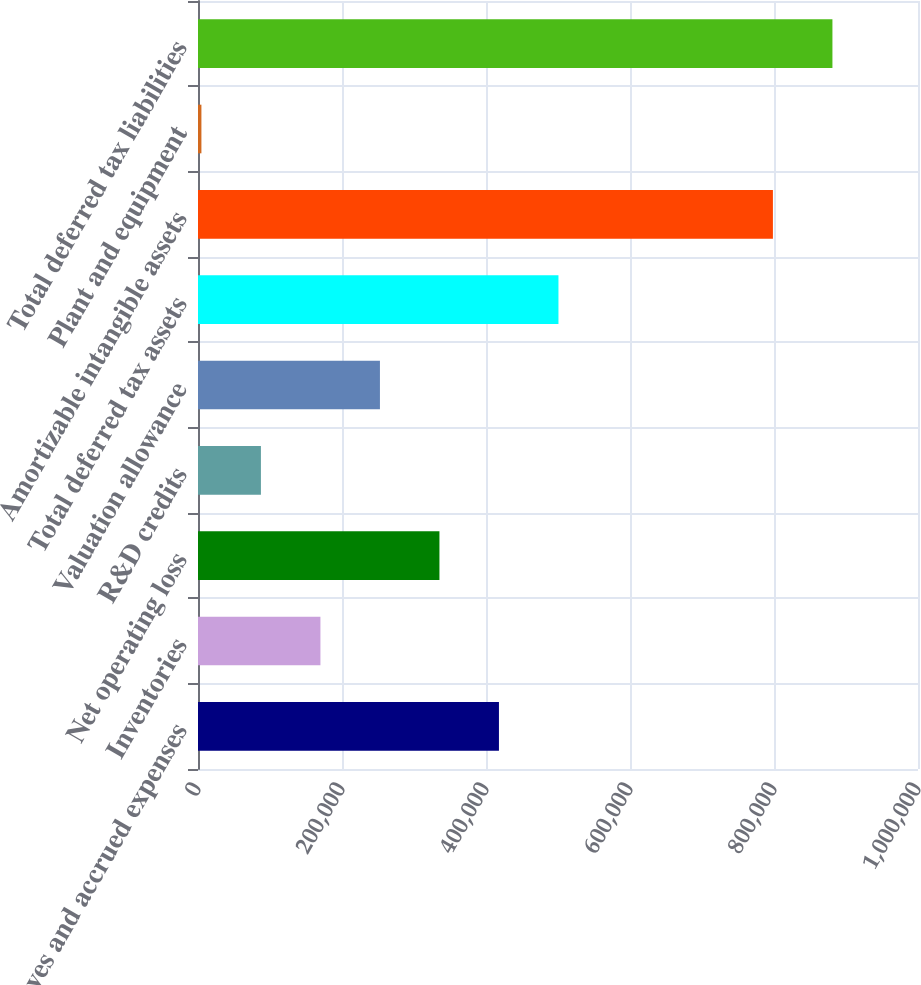<chart> <loc_0><loc_0><loc_500><loc_500><bar_chart><fcel>Reserves and accrued expenses<fcel>Inventories<fcel>Net operating loss<fcel>R&D credits<fcel>Valuation allowance<fcel>Total deferred tax assets<fcel>Amortizable intangible assets<fcel>Plant and equipment<fcel>Total deferred tax liabilities<nl><fcel>417982<fcel>170038<fcel>335334<fcel>87389.3<fcel>252686<fcel>500631<fcel>798502<fcel>4741<fcel>881150<nl></chart> 